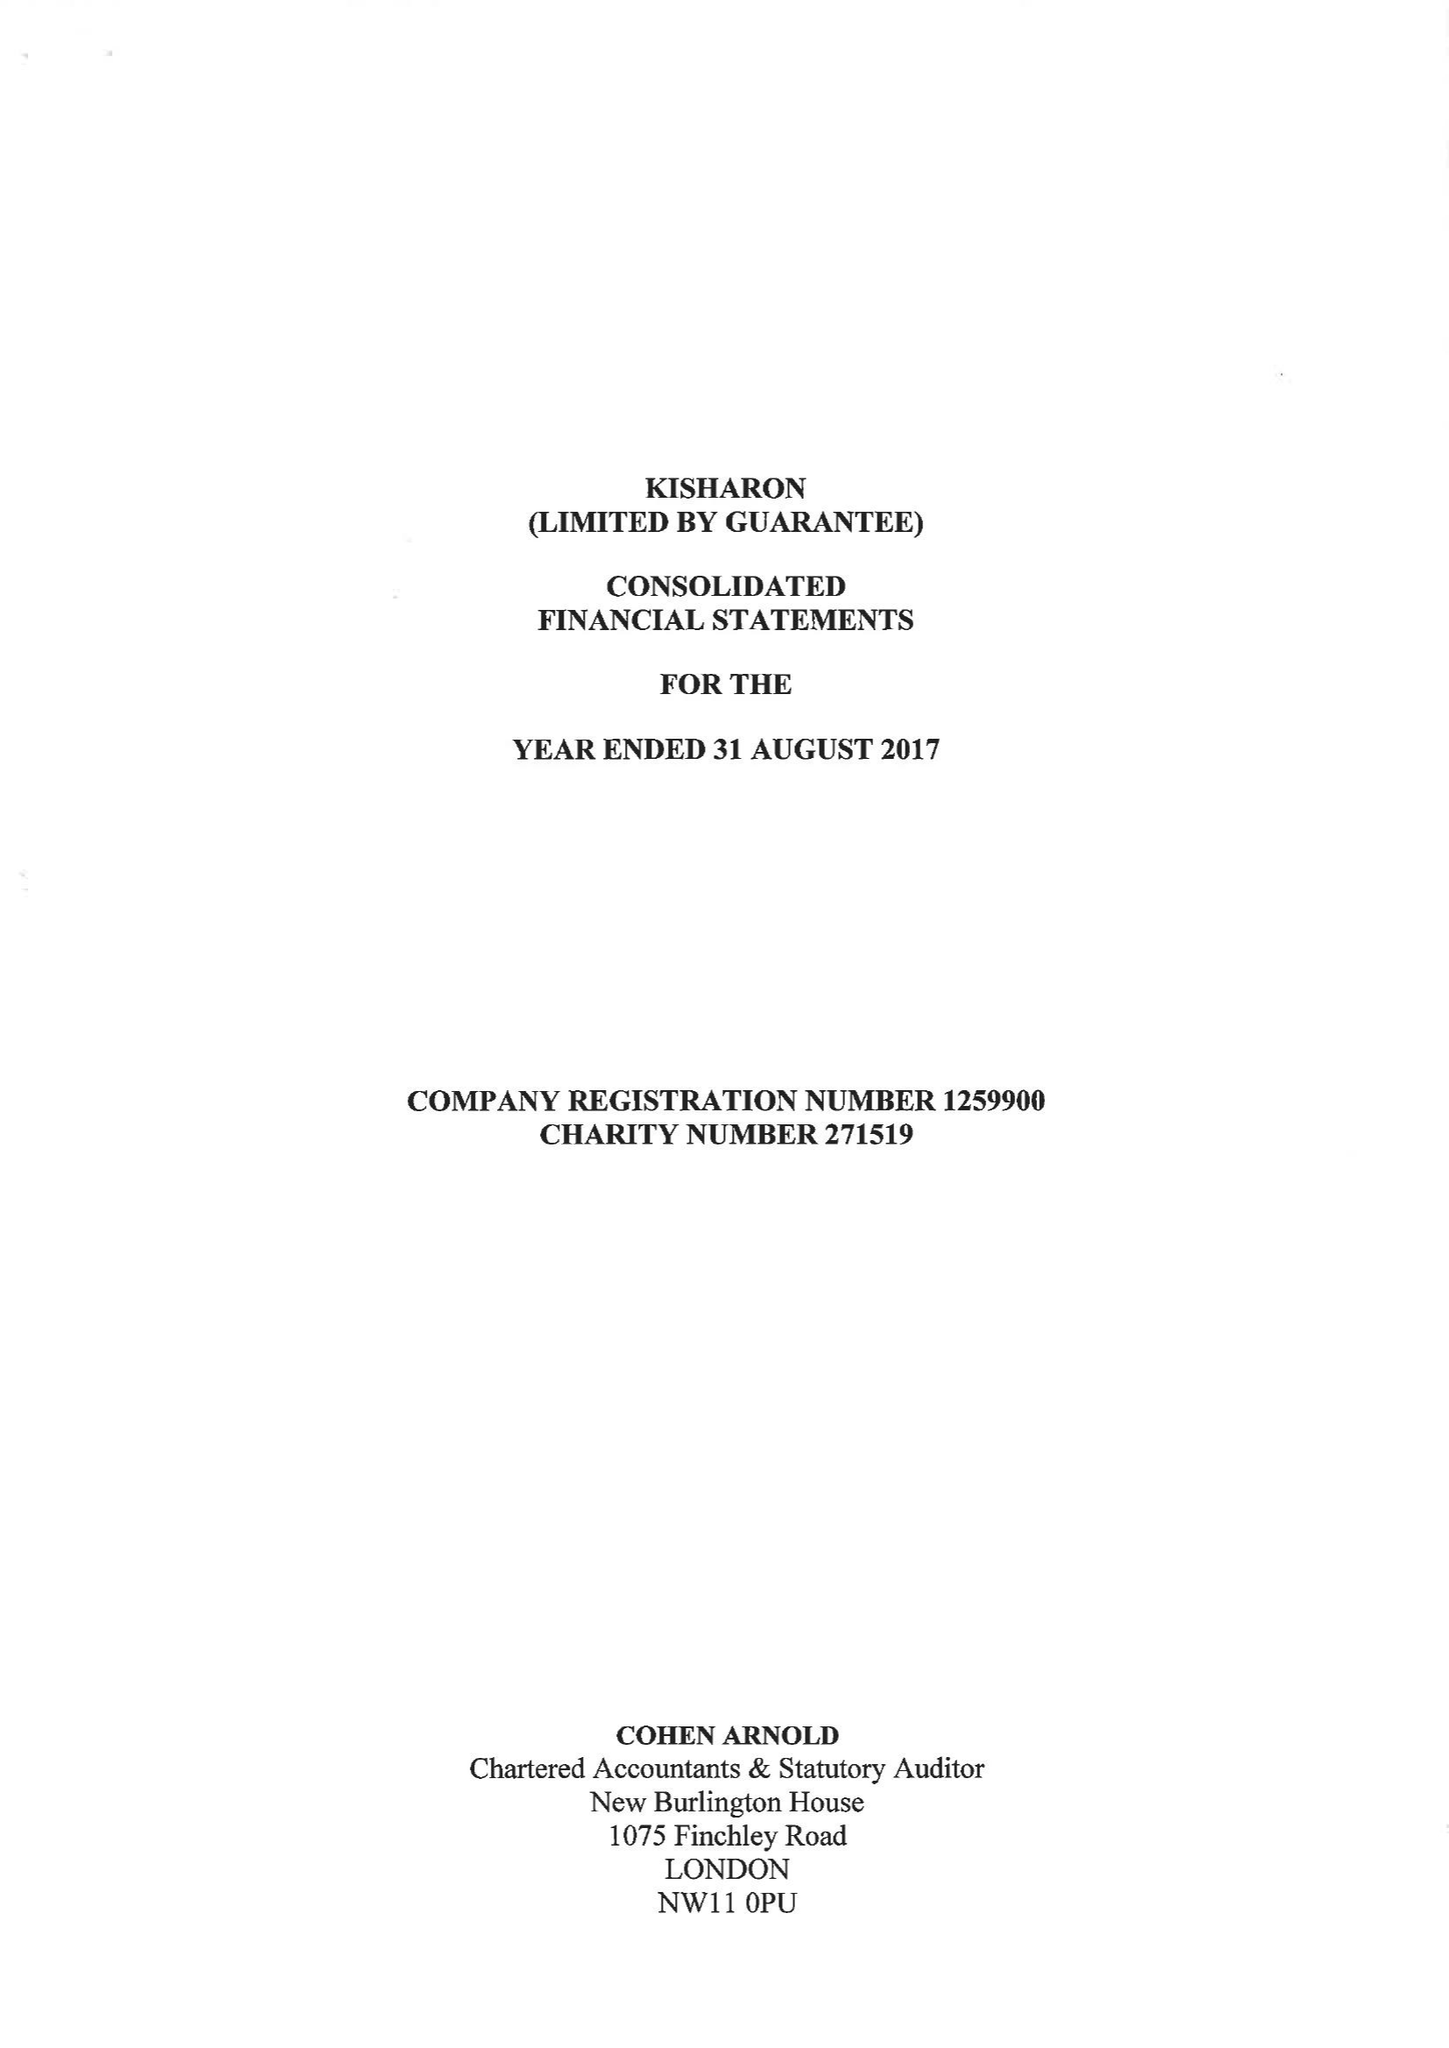What is the value for the address__post_town?
Answer the question using a single word or phrase. LONDON 